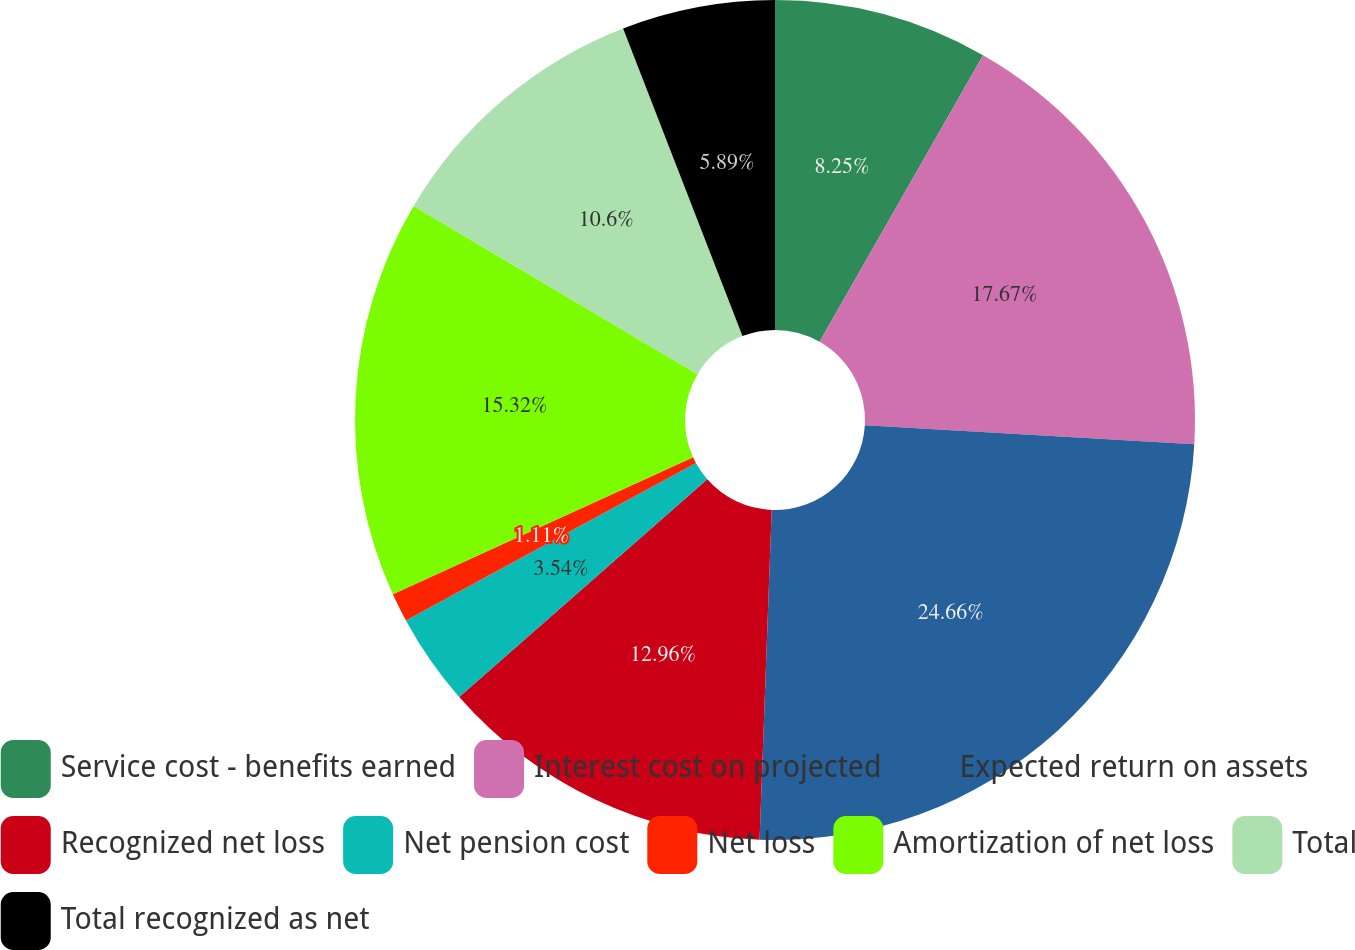Convert chart to OTSL. <chart><loc_0><loc_0><loc_500><loc_500><pie_chart><fcel>Service cost - benefits earned<fcel>Interest cost on projected<fcel>Expected return on assets<fcel>Recognized net loss<fcel>Net pension cost<fcel>Net loss<fcel>Amortization of net loss<fcel>Total<fcel>Total recognized as net<nl><fcel>8.25%<fcel>17.67%<fcel>24.67%<fcel>12.96%<fcel>3.54%<fcel>1.11%<fcel>15.32%<fcel>10.6%<fcel>5.89%<nl></chart> 